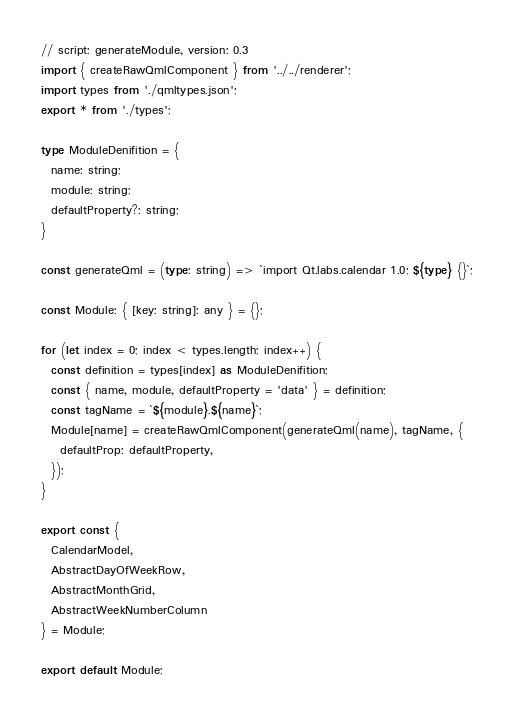Convert code to text. <code><loc_0><loc_0><loc_500><loc_500><_TypeScript_>// script: generateModule, version: 0.3
import { createRawQmlComponent } from '../../renderer';
import types from './qmltypes.json';
export * from './types';

type ModuleDenifition = {
  name: string;
  module: string;
  defaultProperty?: string;
}

const generateQml = (type: string) => `import Qt.labs.calendar 1.0; ${type} {}`;

const Module: { [key: string]: any } = {};

for (let index = 0; index < types.length; index++) {
  const definition = types[index] as ModuleDenifition;
  const { name, module, defaultProperty = 'data' } = definition;
  const tagName = `${module}.${name}`;
  Module[name] = createRawQmlComponent(generateQml(name), tagName, {
    defaultProp: defaultProperty,
  });
}

export const {
  CalendarModel,
  AbstractDayOfWeekRow,
  AbstractMonthGrid,
  AbstractWeekNumberColumn
} = Module;

export default Module;
</code> 